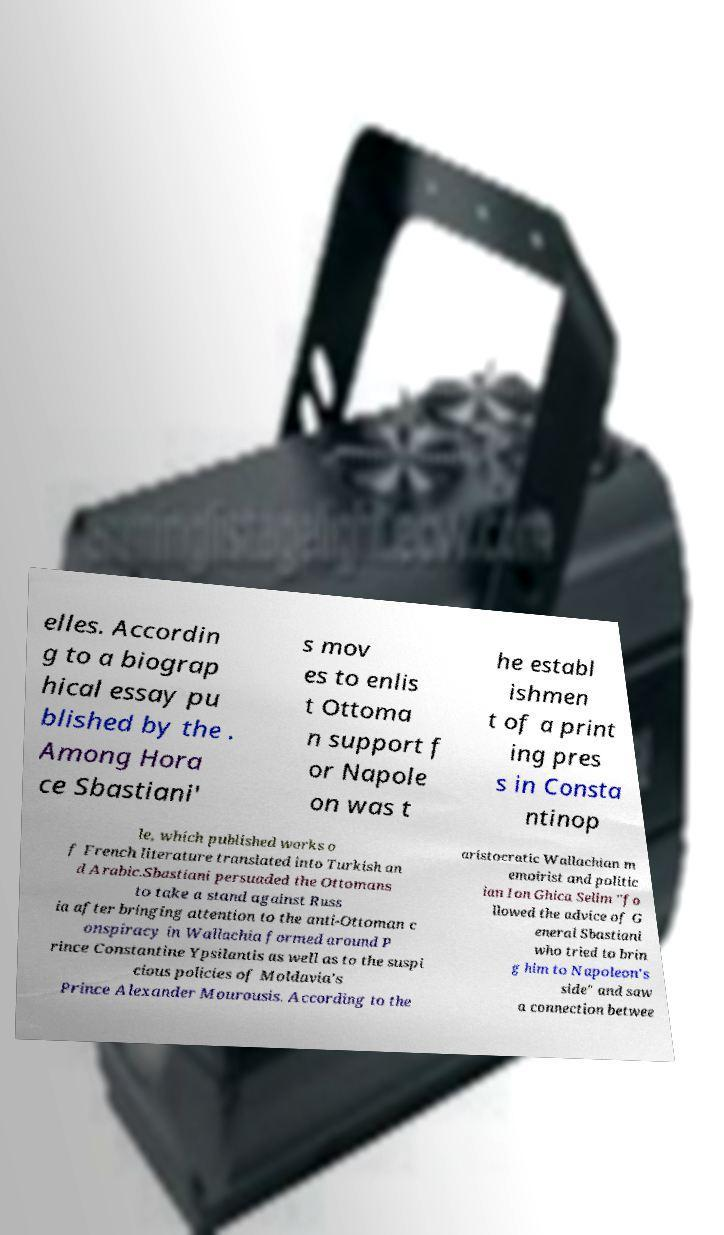For documentation purposes, I need the text within this image transcribed. Could you provide that? elles. Accordin g to a biograp hical essay pu blished by the . Among Hora ce Sbastiani' s mov es to enlis t Ottoma n support f or Napole on was t he establ ishmen t of a print ing pres s in Consta ntinop le, which published works o f French literature translated into Turkish an d Arabic.Sbastiani persuaded the Ottomans to take a stand against Russ ia after bringing attention to the anti-Ottoman c onspiracy in Wallachia formed around P rince Constantine Ypsilantis as well as to the suspi cious policies of Moldavia's Prince Alexander Mourousis. According to the aristocratic Wallachian m emoirist and politic ian Ion Ghica Selim "fo llowed the advice of G eneral Sbastiani who tried to brin g him to Napoleon's side" and saw a connection betwee 